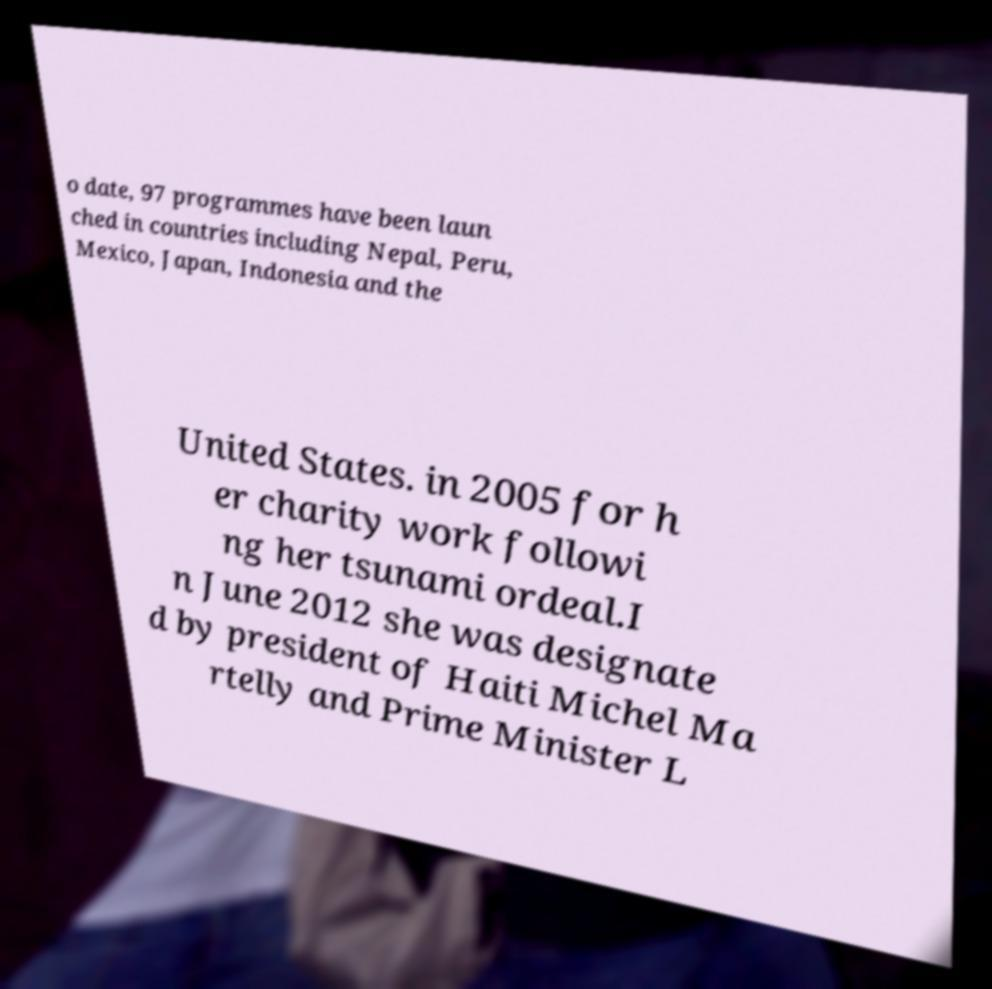Could you assist in decoding the text presented in this image and type it out clearly? o date, 97 programmes have been laun ched in countries including Nepal, Peru, Mexico, Japan, Indonesia and the United States. in 2005 for h er charity work followi ng her tsunami ordeal.I n June 2012 she was designate d by president of Haiti Michel Ma rtelly and Prime Minister L 